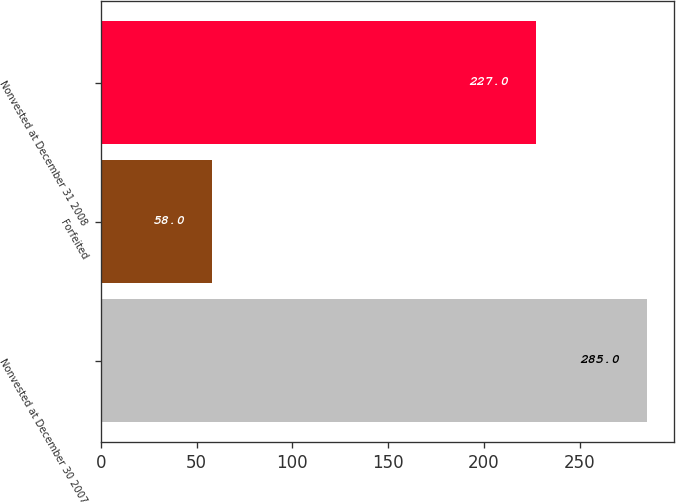<chart> <loc_0><loc_0><loc_500><loc_500><bar_chart><fcel>Nonvested at December 30 2007<fcel>Forfeited<fcel>Nonvested at December 31 2008<nl><fcel>285<fcel>58<fcel>227<nl></chart> 